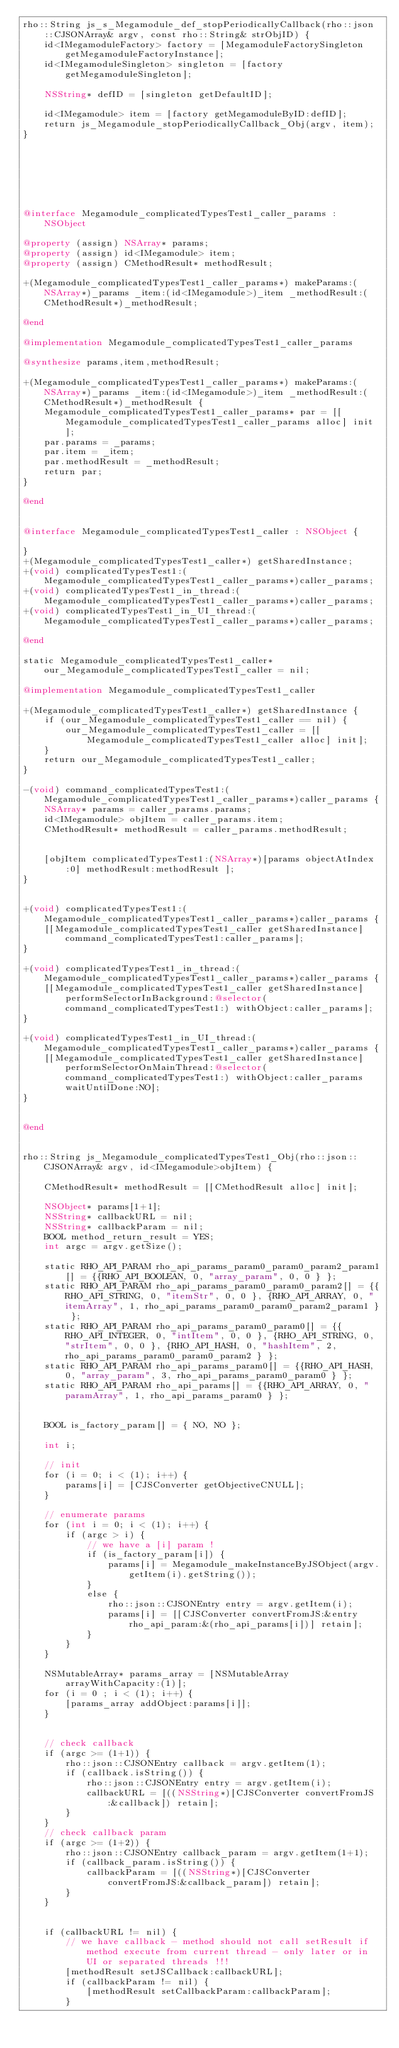Convert code to text. <code><loc_0><loc_0><loc_500><loc_500><_ObjectiveC_>rho::String js_s_Megamodule_def_stopPeriodicallyCallback(rho::json::CJSONArray& argv, const rho::String& strObjID) {
    id<IMegamoduleFactory> factory = [MegamoduleFactorySingleton getMegamoduleFactoryInstance];
    id<IMegamoduleSingleton> singleton = [factory getMegamoduleSingleton];

    NSString* defID = [singleton getDefaultID];

    id<IMegamodule> item = [factory getMegamoduleByID:defID];
    return js_Megamodule_stopPeriodicallyCallback_Obj(argv, item);
}







@interface Megamodule_complicatedTypesTest1_caller_params : NSObject

@property (assign) NSArray* params;
@property (assign) id<IMegamodule> item;
@property (assign) CMethodResult* methodResult;

+(Megamodule_complicatedTypesTest1_caller_params*) makeParams:(NSArray*)_params _item:(id<IMegamodule>)_item _methodResult:(CMethodResult*)_methodResult;

@end

@implementation Megamodule_complicatedTypesTest1_caller_params

@synthesize params,item,methodResult;

+(Megamodule_complicatedTypesTest1_caller_params*) makeParams:(NSArray*)_params _item:(id<IMegamodule>)_item _methodResult:(CMethodResult*)_methodResult {
    Megamodule_complicatedTypesTest1_caller_params* par = [[Megamodule_complicatedTypesTest1_caller_params alloc] init];
    par.params = _params;
    par.item = _item;
    par.methodResult = _methodResult;
    return par;
}

@end


@interface Megamodule_complicatedTypesTest1_caller : NSObject {

}
+(Megamodule_complicatedTypesTest1_caller*) getSharedInstance;
+(void) complicatedTypesTest1:(Megamodule_complicatedTypesTest1_caller_params*)caller_params;
+(void) complicatedTypesTest1_in_thread:(Megamodule_complicatedTypesTest1_caller_params*)caller_params;
+(void) complicatedTypesTest1_in_UI_thread:(Megamodule_complicatedTypesTest1_caller_params*)caller_params;

@end

static Megamodule_complicatedTypesTest1_caller* our_Megamodule_complicatedTypesTest1_caller = nil;

@implementation Megamodule_complicatedTypesTest1_caller

+(Megamodule_complicatedTypesTest1_caller*) getSharedInstance {
    if (our_Megamodule_complicatedTypesTest1_caller == nil) {
        our_Megamodule_complicatedTypesTest1_caller = [[Megamodule_complicatedTypesTest1_caller alloc] init];
    }
    return our_Megamodule_complicatedTypesTest1_caller;
}

-(void) command_complicatedTypesTest1:(Megamodule_complicatedTypesTest1_caller_params*)caller_params {
    NSArray* params = caller_params.params;
    id<IMegamodule> objItem = caller_params.item;
    CMethodResult* methodResult = caller_params.methodResult;

    
    [objItem complicatedTypesTest1:(NSArray*)[params objectAtIndex:0] methodResult:methodResult ];
}


+(void) complicatedTypesTest1:(Megamodule_complicatedTypesTest1_caller_params*)caller_params {
    [[Megamodule_complicatedTypesTest1_caller getSharedInstance] command_complicatedTypesTest1:caller_params];
}

+(void) complicatedTypesTest1_in_thread:(Megamodule_complicatedTypesTest1_caller_params*)caller_params {
    [[Megamodule_complicatedTypesTest1_caller getSharedInstance] performSelectorInBackground:@selector(command_complicatedTypesTest1:) withObject:caller_params];
}

+(void) complicatedTypesTest1_in_UI_thread:(Megamodule_complicatedTypesTest1_caller_params*)caller_params {
    [[Megamodule_complicatedTypesTest1_caller getSharedInstance] performSelectorOnMainThread:@selector(command_complicatedTypesTest1:) withObject:caller_params waitUntilDone:NO];
}


@end


rho::String js_Megamodule_complicatedTypesTest1_Obj(rho::json::CJSONArray& argv, id<IMegamodule>objItem) {

    CMethodResult* methodResult = [[CMethodResult alloc] init];

    NSObject* params[1+1];
    NSString* callbackURL = nil;
    NSString* callbackParam = nil;
    BOOL method_return_result = YES;
    int argc = argv.getSize();
    
    static RHO_API_PARAM rho_api_params_param0_param0_param2_param1[] = {{RHO_API_BOOLEAN, 0, "array_param", 0, 0 } };
    static RHO_API_PARAM rho_api_params_param0_param0_param2[] = {{RHO_API_STRING, 0, "itemStr", 0, 0 }, {RHO_API_ARRAY, 0, "itemArray", 1, rho_api_params_param0_param0_param2_param1 } };
    static RHO_API_PARAM rho_api_params_param0_param0[] = {{RHO_API_INTEGER, 0, "intItem", 0, 0 }, {RHO_API_STRING, 0, "strItem", 0, 0 }, {RHO_API_HASH, 0, "hashItem", 2, rho_api_params_param0_param0_param2 } };
    static RHO_API_PARAM rho_api_params_param0[] = {{RHO_API_HASH, 0, "array_param", 3, rho_api_params_param0_param0 } };
    static RHO_API_PARAM rho_api_params[] = {{RHO_API_ARRAY, 0, "paramArray", 1, rho_api_params_param0 } };

    
    BOOL is_factory_param[] = { NO, NO };

    int i;

    // init
    for (i = 0; i < (1); i++) {
        params[i] = [CJSConverter getObjectiveCNULL];
    }

    // enumerate params
    for (int i = 0; i < (1); i++) {
        if (argc > i) {
            // we have a [i] param !
            if (is_factory_param[i]) {
                params[i] = Megamodule_makeInstanceByJSObject(argv.getItem(i).getString());
            }
            else {
                rho::json::CJSONEntry entry = argv.getItem(i);
                params[i] = [[CJSConverter convertFromJS:&entry rho_api_param:&(rho_api_params[i])] retain];
            }
        }
    }

    NSMutableArray* params_array = [NSMutableArray arrayWithCapacity:(1)];
    for (i = 0 ; i < (1); i++) {
        [params_array addObject:params[i]];
    }

    
    // check callback
    if (argc >= (1+1)) {
        rho::json::CJSONEntry callback = argv.getItem(1);
        if (callback.isString()) {
            rho::json::CJSONEntry entry = argv.getItem(i);
            callbackURL = [((NSString*)[CJSConverter convertFromJS:&callback]) retain];
        }
    }
    // check callback param
    if (argc >= (1+2)) {
        rho::json::CJSONEntry callback_param = argv.getItem(1+1);
        if (callback_param.isString()) {
            callbackParam = [((NSString*)[CJSConverter convertFromJS:&callback_param]) retain];
        }
    }
    

    if (callbackURL != nil) {
        // we have callback - method should not call setResult if method execute from current thread - only later or in UI or separated threads !!!
        [methodResult setJSCallback:callbackURL];
        if (callbackParam != nil) {
            [methodResult setCallbackParam:callbackParam];
        }
        </code> 